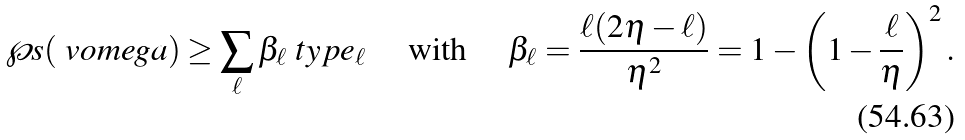<formula> <loc_0><loc_0><loc_500><loc_500>\wp s ( \ v o m e g a ) & \geq \sum _ { \ell } \beta _ { \ell } \ t y p e _ { \ell } \quad \text { with } \quad \beta _ { \ell } = \frac { \ell ( 2 \eta - \ell ) } { \eta ^ { 2 } } = 1 - \left ( 1 - \frac { \ell } { \eta } \right ) ^ { 2 } .</formula> 